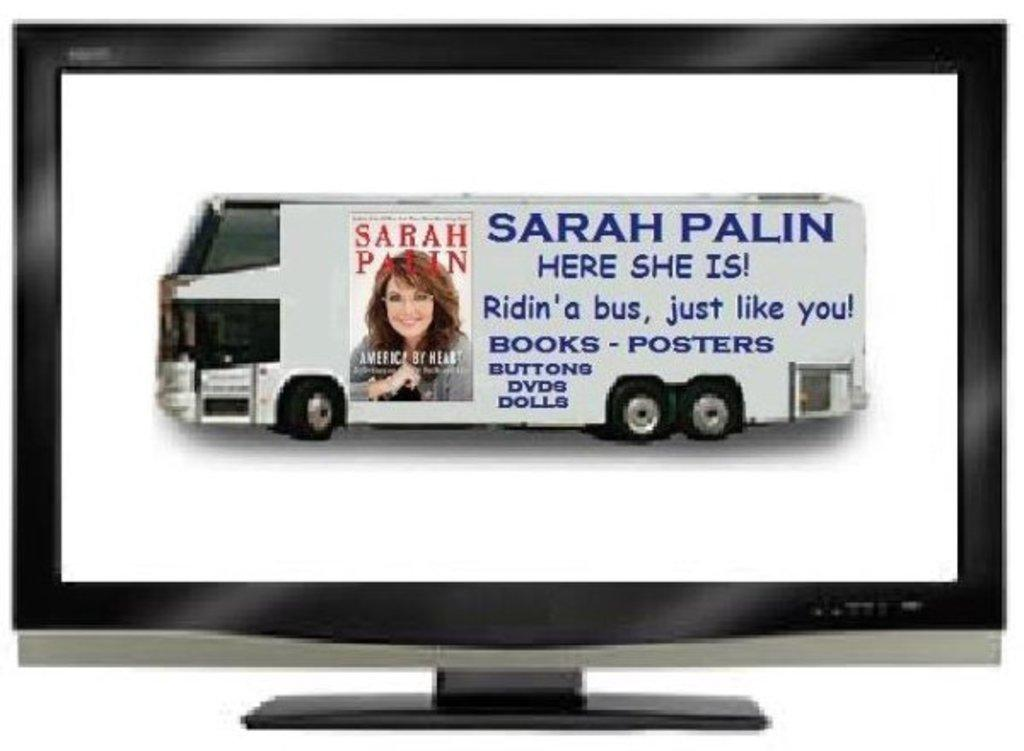<image>
Create a compact narrative representing the image presented. Sarah Palin RV that says Here She is! Ridin' a bus, just like you! Books-Posters Buttons,DVD's Dolls. 